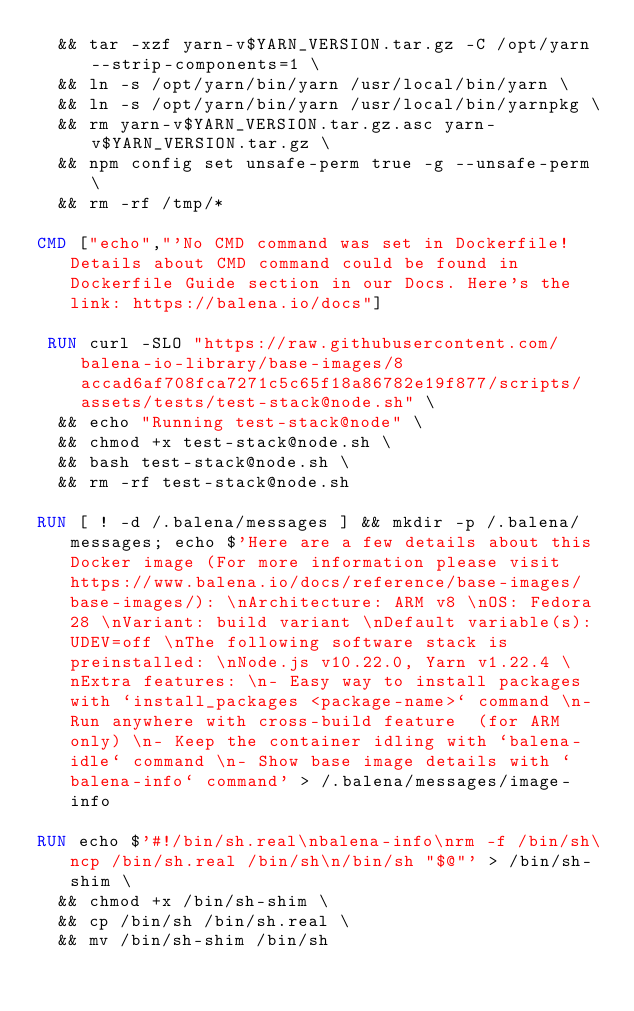<code> <loc_0><loc_0><loc_500><loc_500><_Dockerfile_>	&& tar -xzf yarn-v$YARN_VERSION.tar.gz -C /opt/yarn --strip-components=1 \
	&& ln -s /opt/yarn/bin/yarn /usr/local/bin/yarn \
	&& ln -s /opt/yarn/bin/yarn /usr/local/bin/yarnpkg \
	&& rm yarn-v$YARN_VERSION.tar.gz.asc yarn-v$YARN_VERSION.tar.gz \
	&& npm config set unsafe-perm true -g --unsafe-perm \
	&& rm -rf /tmp/*

CMD ["echo","'No CMD command was set in Dockerfile! Details about CMD command could be found in Dockerfile Guide section in our Docs. Here's the link: https://balena.io/docs"]

 RUN curl -SLO "https://raw.githubusercontent.com/balena-io-library/base-images/8accad6af708fca7271c5c65f18a86782e19f877/scripts/assets/tests/test-stack@node.sh" \
  && echo "Running test-stack@node" \
  && chmod +x test-stack@node.sh \
  && bash test-stack@node.sh \
  && rm -rf test-stack@node.sh 

RUN [ ! -d /.balena/messages ] && mkdir -p /.balena/messages; echo $'Here are a few details about this Docker image (For more information please visit https://www.balena.io/docs/reference/base-images/base-images/): \nArchitecture: ARM v8 \nOS: Fedora 28 \nVariant: build variant \nDefault variable(s): UDEV=off \nThe following software stack is preinstalled: \nNode.js v10.22.0, Yarn v1.22.4 \nExtra features: \n- Easy way to install packages with `install_packages <package-name>` command \n- Run anywhere with cross-build feature  (for ARM only) \n- Keep the container idling with `balena-idle` command \n- Show base image details with `balena-info` command' > /.balena/messages/image-info

RUN echo $'#!/bin/sh.real\nbalena-info\nrm -f /bin/sh\ncp /bin/sh.real /bin/sh\n/bin/sh "$@"' > /bin/sh-shim \
	&& chmod +x /bin/sh-shim \
	&& cp /bin/sh /bin/sh.real \
	&& mv /bin/sh-shim /bin/sh</code> 